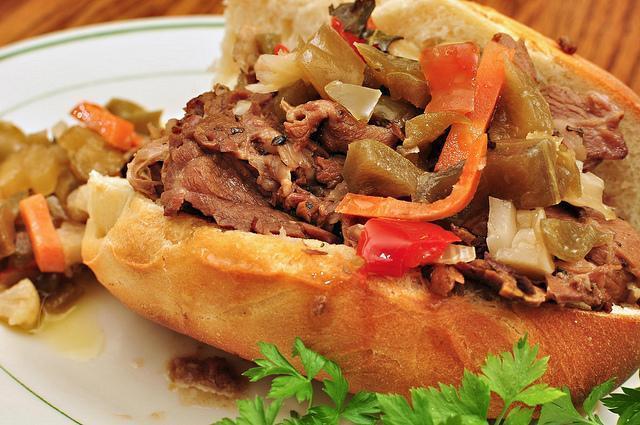How many carrots are there?
Give a very brief answer. 2. How many bushes are to the left of the woman on the park bench?
Give a very brief answer. 0. 